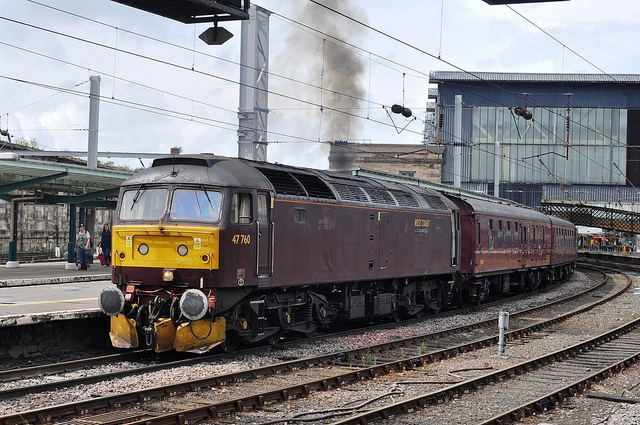Describe the objects in this image and their specific colors. I can see train in lavender, black, gray, and darkgray tones, people in lavender, black, gray, darkgray, and navy tones, people in lavender, black, gray, maroon, and navy tones, suitcase in lavender, navy, darkblue, purple, and gray tones, and suitcase in lavender, maroon, black, purple, and brown tones in this image. 